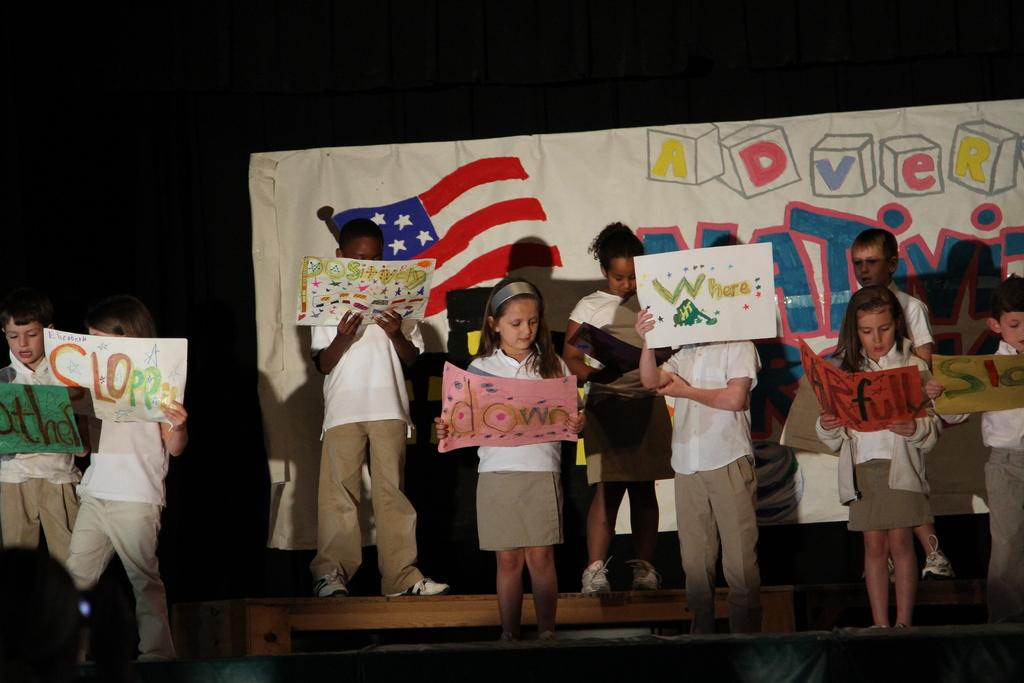What is the main subject of the image? The main subject of the image is a group of children. What are the children doing in the image? The children are standing and holding papers. Can you describe any other objects or features in the image? There appears to be a bench in the image, and there might be a banner as well. How would you describe the lighting or color of the background in the image? The background of the image looks dark. What type of yarn is being used to create the scene in the image? There is no mention of yarn or any crafting materials in the image. The image features a group of children standing and holding papers, a bench, and possibly a banner. 